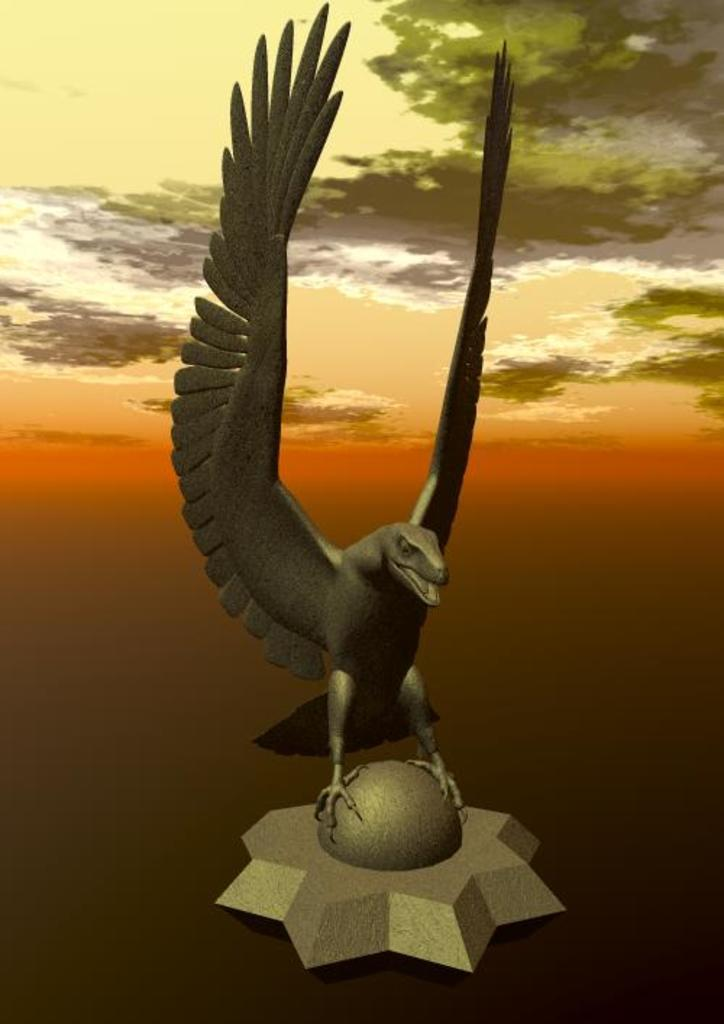What is the main subject of the picture? The main subject of the picture is a bird-like sculpture. What can be seen in the background of the picture? The background of the picture is the sky. What type of nail is being used to hold the gold in the image? There is no nail or gold present in the image; it features a bird-like sculpture and the sky as the background. What show is being performed by the bird in the image? There is no bird performing a show in the image; it is a bird-like sculpture. 